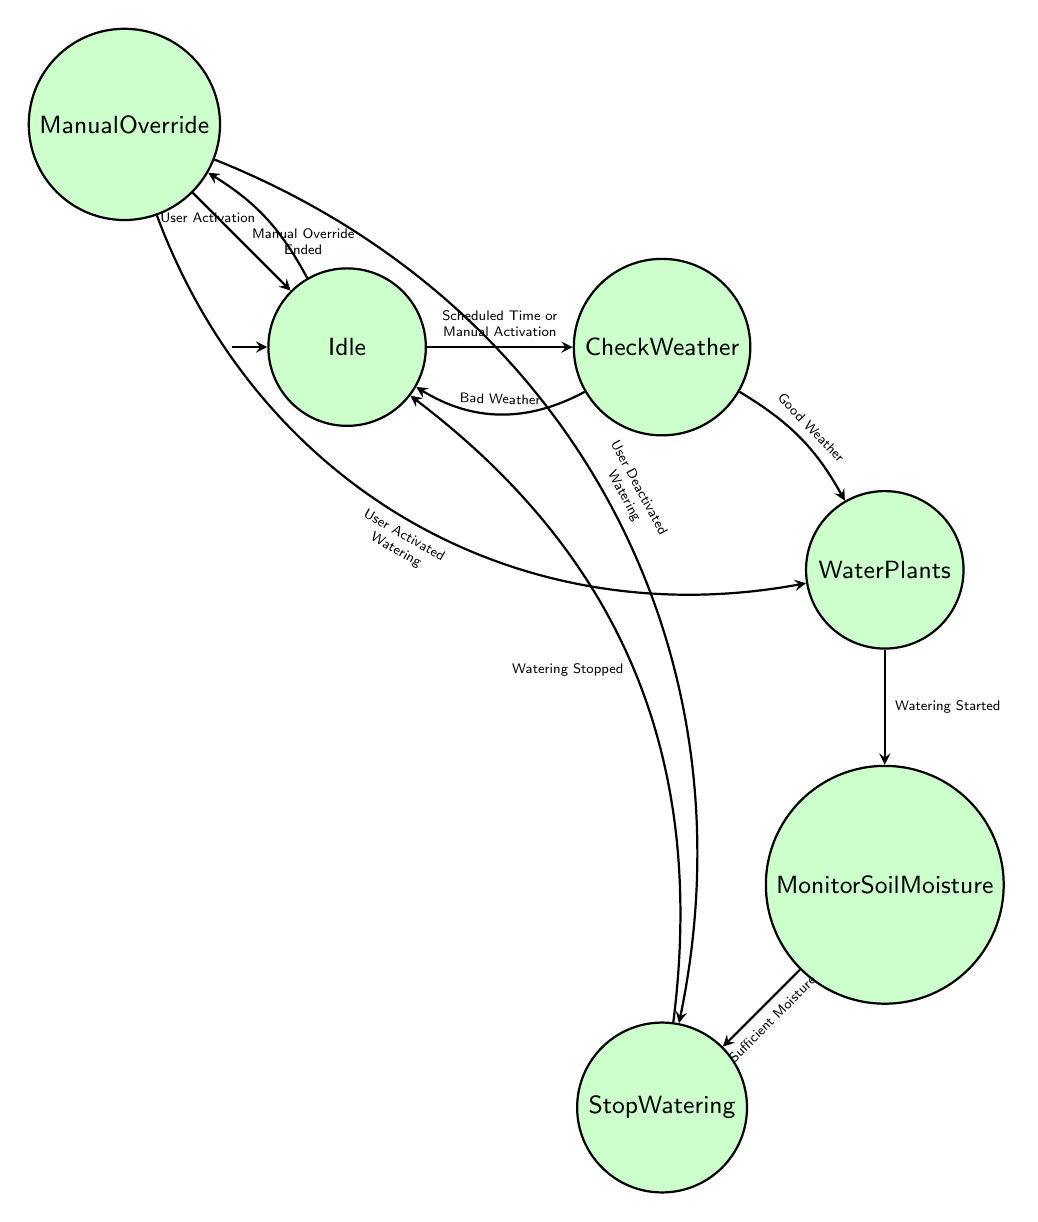What is the initial state of the system? The diagram indicates that the initial state is "Idle," which means the system is waiting for action.
Answer: Idle How many states are present in the system? By counting the nodes in the diagram, there are a total of six states represented.
Answer: 6 What triggers the transition from 'Idle' to 'Check Weather'? The transition to 'Check Weather' is triggered by either a "Scheduled Time or Manual Activation," which means the system activates for watering.
Answer: Scheduled Time or Manual Activation Which state follows 'Water Plants'? The next state after 'Water Plants' is 'Monitor Soil Moisture,' as the diagram shows a direct transition from the watering action to monitoring.
Answer: Monitor Soil Moisture What action occurs when there are sufficient moisture levels detected? When sufficient moisture is detected, the action is to "Stop watering," indicating that the irrigation process should cease.
Answer: Stop watering What happens after 'Manual Override' is initiated? Once 'Manual Override' is activated by the user, the system can either move to 'Water Plants' if watering is activated or 'Stop Watering' if deactivation occurs.
Answer: Water Plants or Stop Watering How does the system respond to bad weather conditions during 'Check Weather'? If bad weather conditions are detected during 'Check Weather', the system transitions back to 'Idle,' indicating no watering will occur.
Answer: Idle What is the final state after watering has stopped? The final state that the system reaches after watering has stopped is 'Idle,' indicating completion of the irrigation cycle.
Answer: Idle How many transitions lead to the 'Water Plants' state? There are two transitions that can lead to the 'Water Plants' state: one from 'Check Weather' with good weather and another from 'Manual Override' when user watering is activated.
Answer: 2 